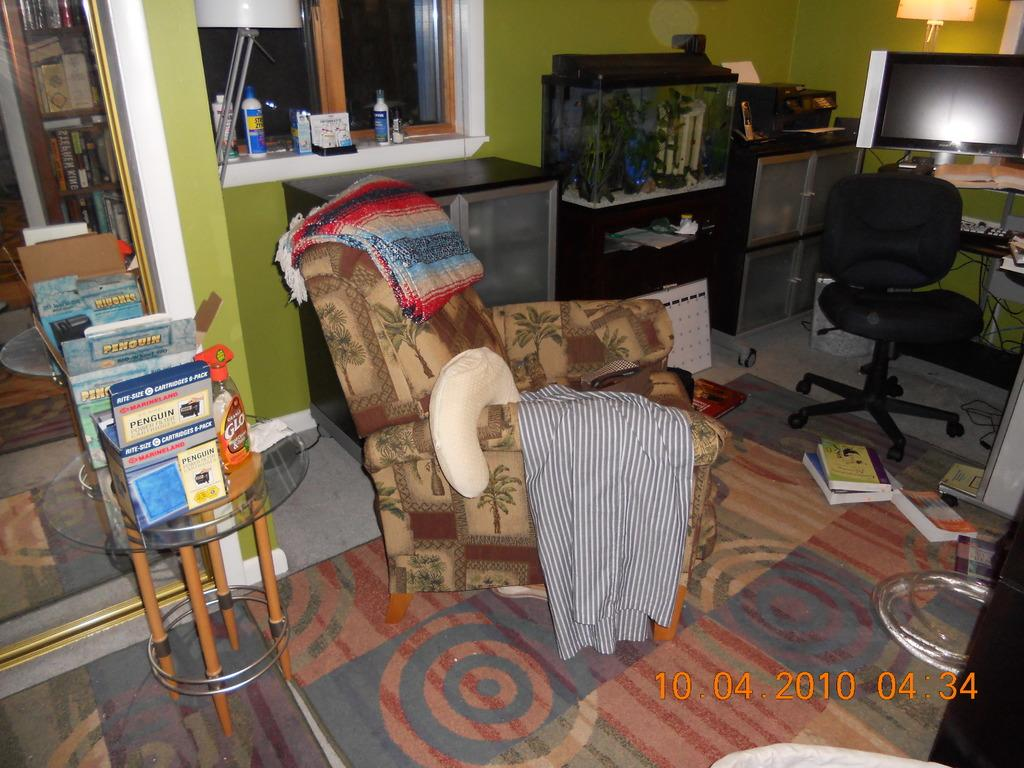Provide a one-sentence caption for the provided image. A photo of a rocking chair in a living room was taken on October 4 ,2010. 